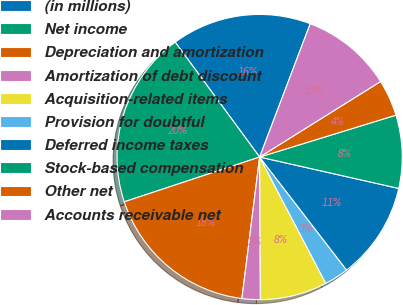Convert chart to OTSL. <chart><loc_0><loc_0><loc_500><loc_500><pie_chart><fcel>(in millions)<fcel>Net income<fcel>Depreciation and amortization<fcel>Amortization of debt discount<fcel>Acquisition-related items<fcel>Provision for doubtful<fcel>Deferred income taxes<fcel>Stock-based compensation<fcel>Other net<fcel>Accounts receivable net<nl><fcel>15.86%<fcel>20.0%<fcel>17.93%<fcel>2.07%<fcel>7.59%<fcel>2.76%<fcel>11.03%<fcel>8.28%<fcel>4.14%<fcel>10.34%<nl></chart> 